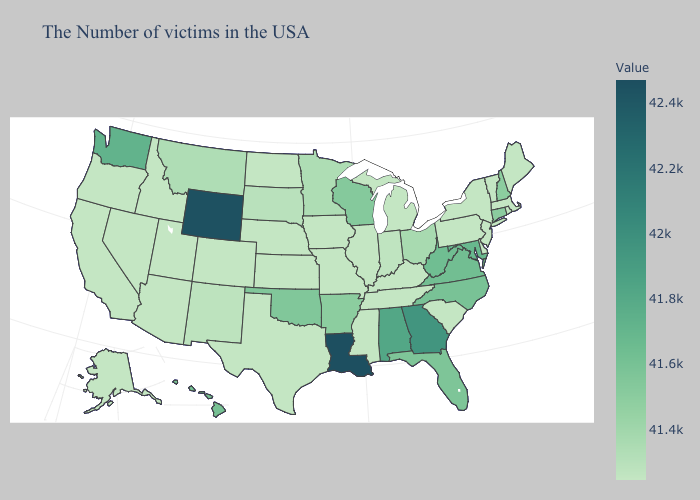Does New Hampshire have the lowest value in the USA?
Short answer required. No. Does Vermont have the highest value in the USA?
Keep it brief. No. Which states have the lowest value in the Northeast?
Give a very brief answer. Maine, Massachusetts, Rhode Island, Vermont, New York, New Jersey, Pennsylvania. Does Louisiana have the highest value in the South?
Give a very brief answer. Yes. Is the legend a continuous bar?
Be succinct. Yes. Among the states that border Texas , does Oklahoma have the lowest value?
Keep it brief. No. Does Tennessee have a higher value than Connecticut?
Concise answer only. No. Does Louisiana have the highest value in the USA?
Concise answer only. Yes. Which states hav the highest value in the MidWest?
Write a very short answer. Wisconsin. Does the map have missing data?
Give a very brief answer. No. Among the states that border North Dakota , does Minnesota have the highest value?
Short answer required. Yes. 